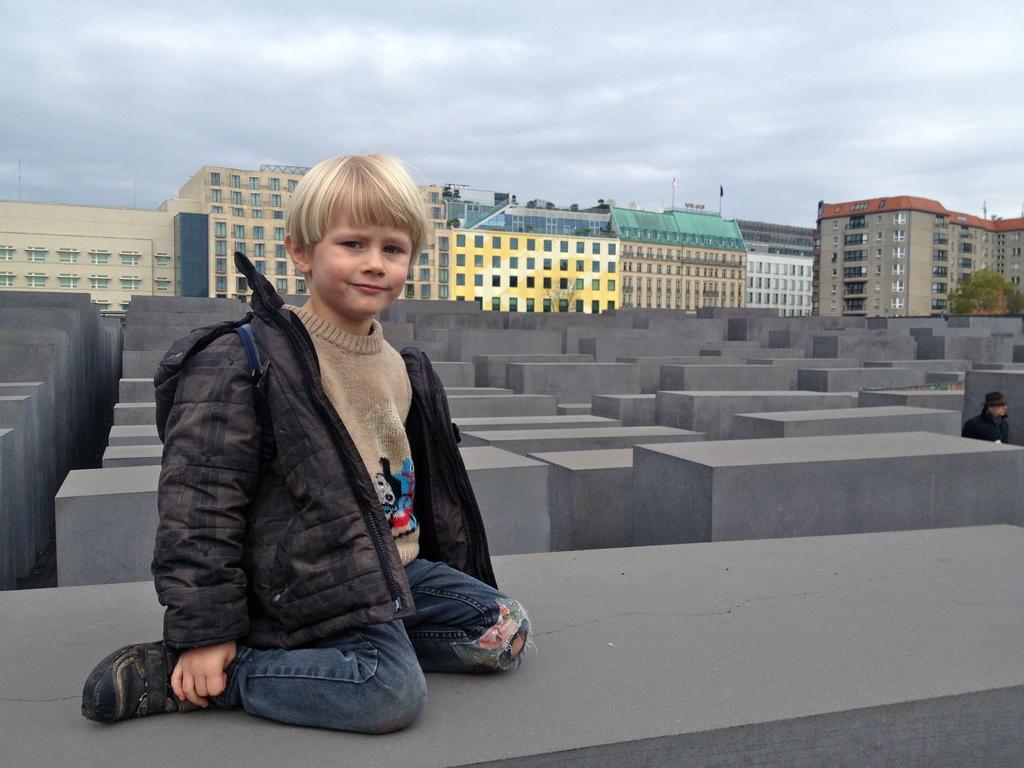In one or two sentences, can you explain what this image depicts? In this image there is a boy sitting on the cement blocks. In the background there are so many buildings one beside the other. At the top there is sky. On the right side there is a tree beside the building. 